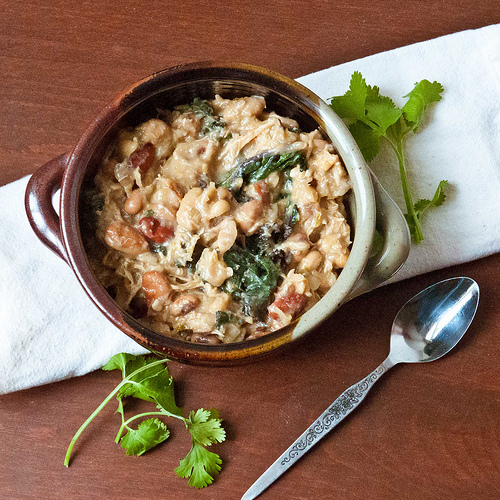<image>
Is the pan on the spoon? No. The pan is not positioned on the spoon. They may be near each other, but the pan is not supported by or resting on top of the spoon. Where is the food in relation to the spoon? Is it behind the spoon? No. The food is not behind the spoon. From this viewpoint, the food appears to be positioned elsewhere in the scene. 